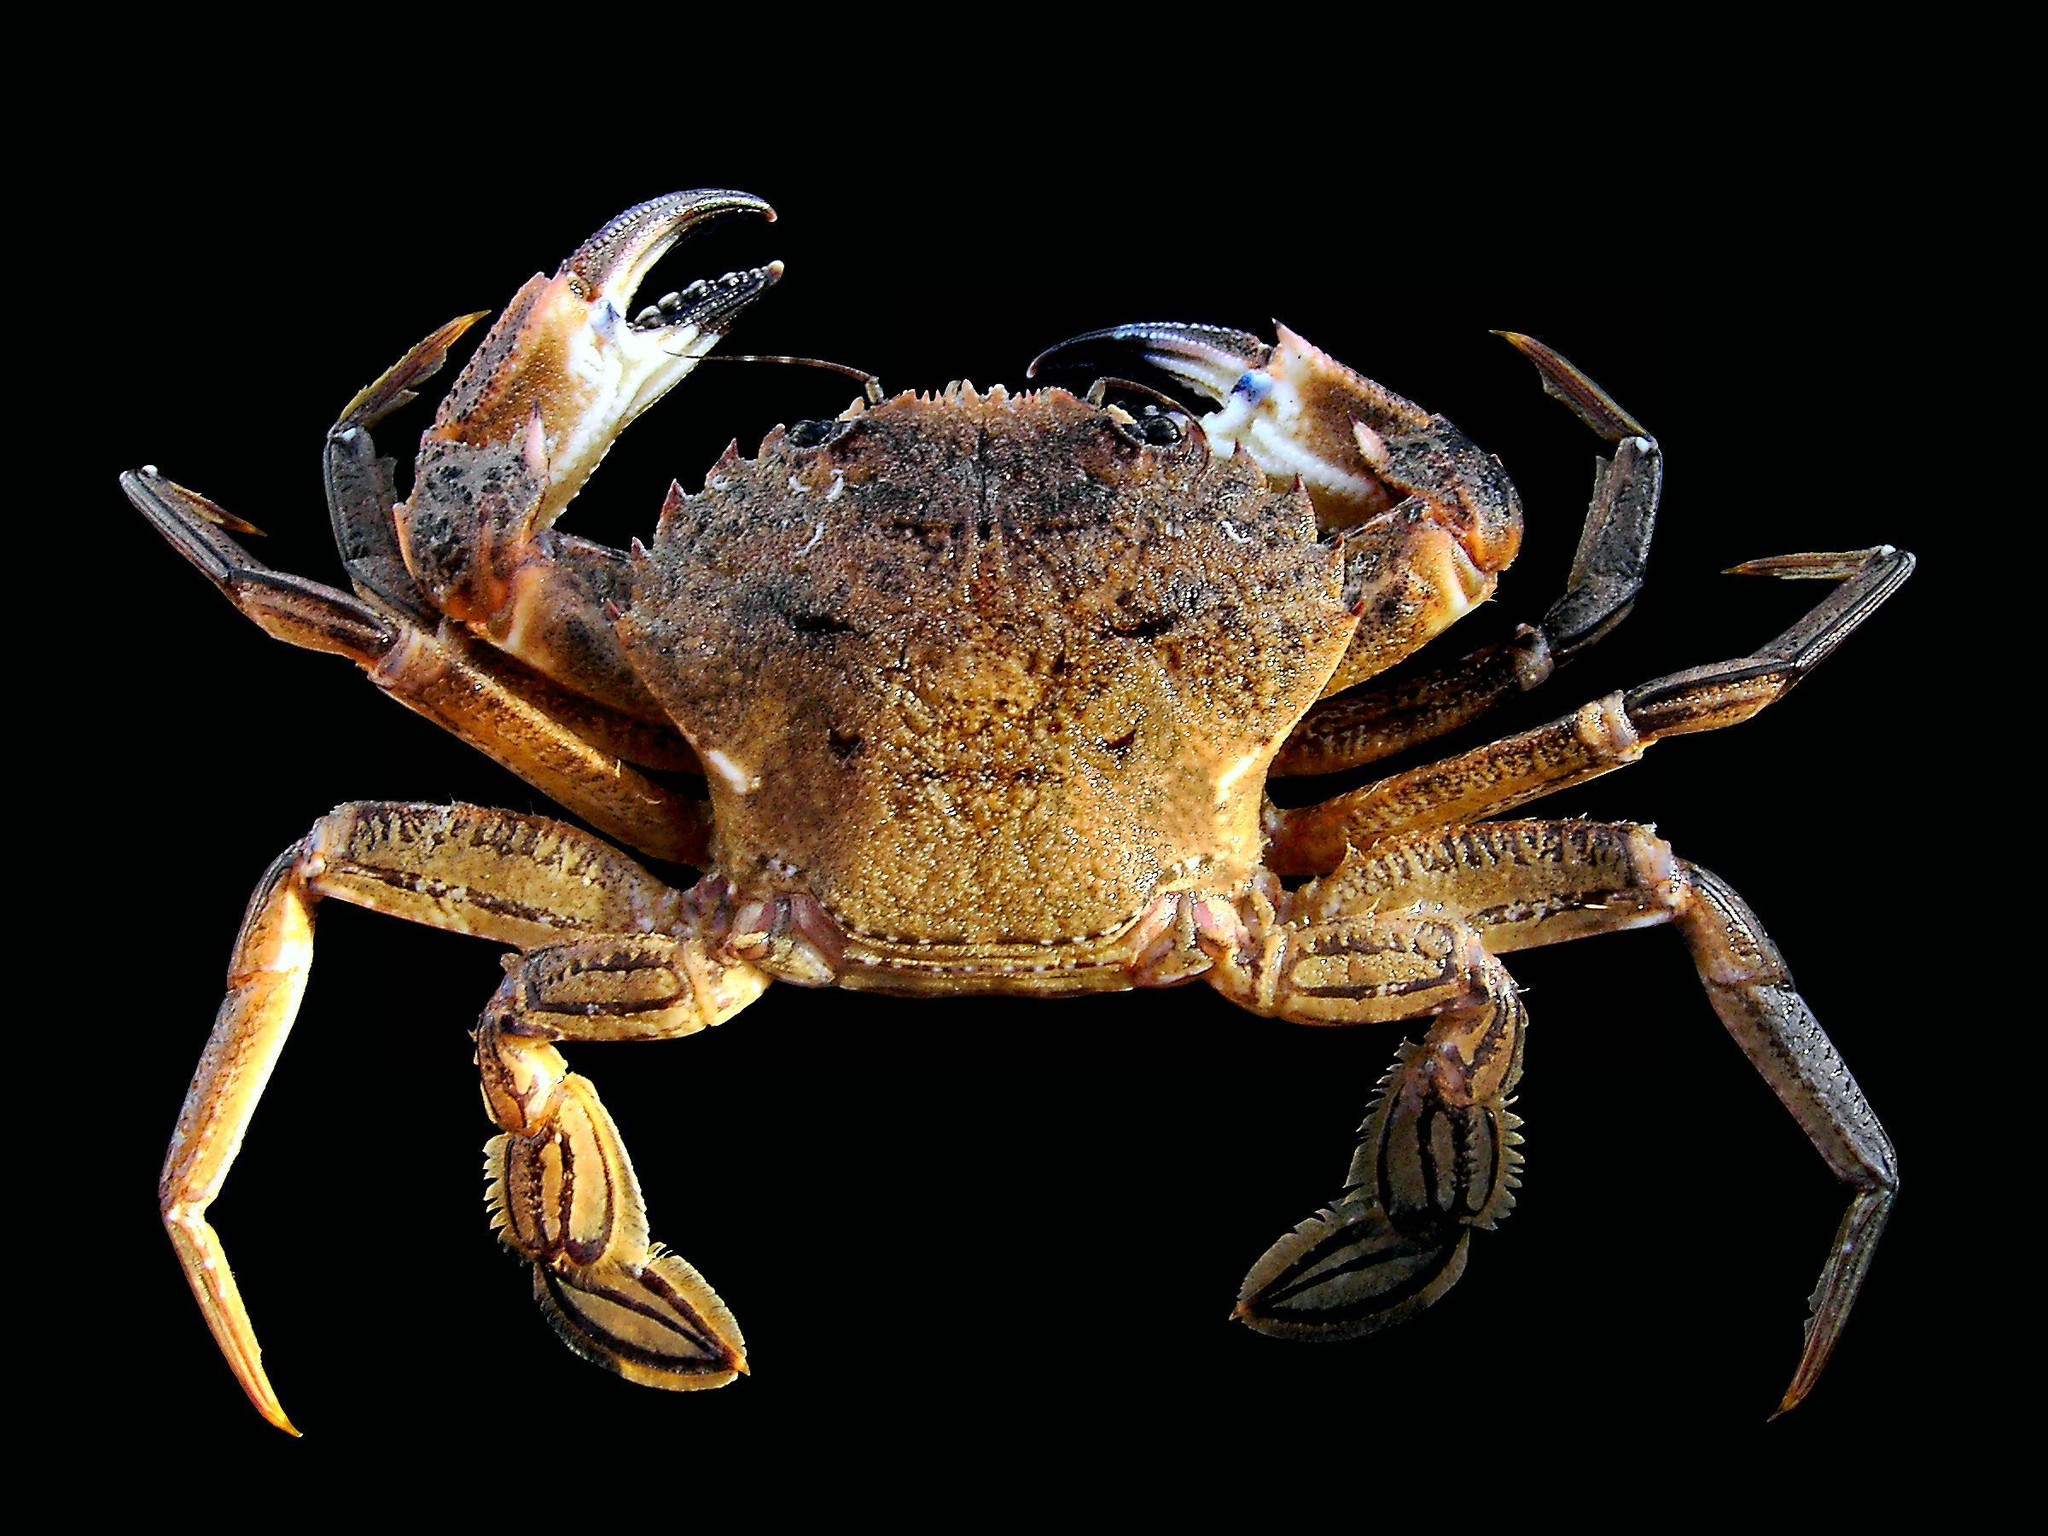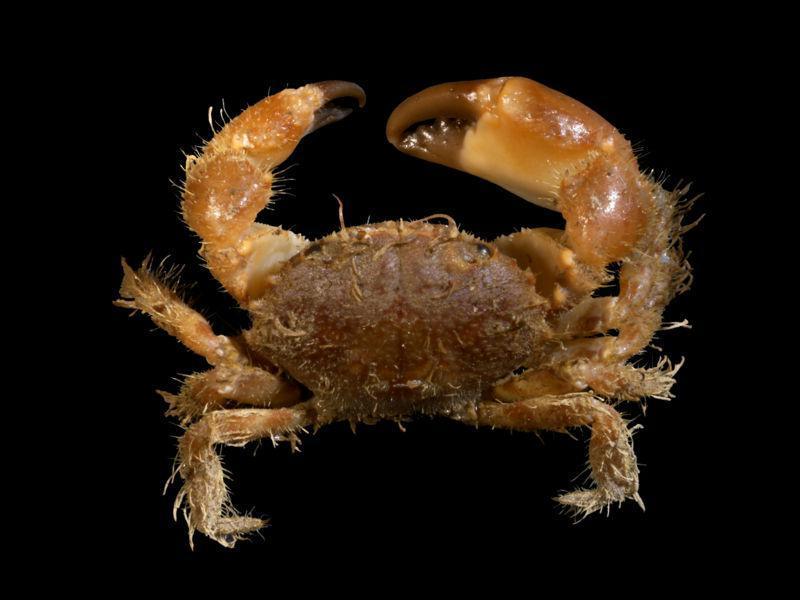The first image is the image on the left, the second image is the image on the right. For the images shown, is this caption "The crabs have the same orientation." true? Answer yes or no. Yes. The first image is the image on the left, the second image is the image on the right. Examine the images to the left and right. Is the description "Each image shows a top-view of a crab with its face and its larger front claws at the top, and its shell facing forward." accurate? Answer yes or no. Yes. 